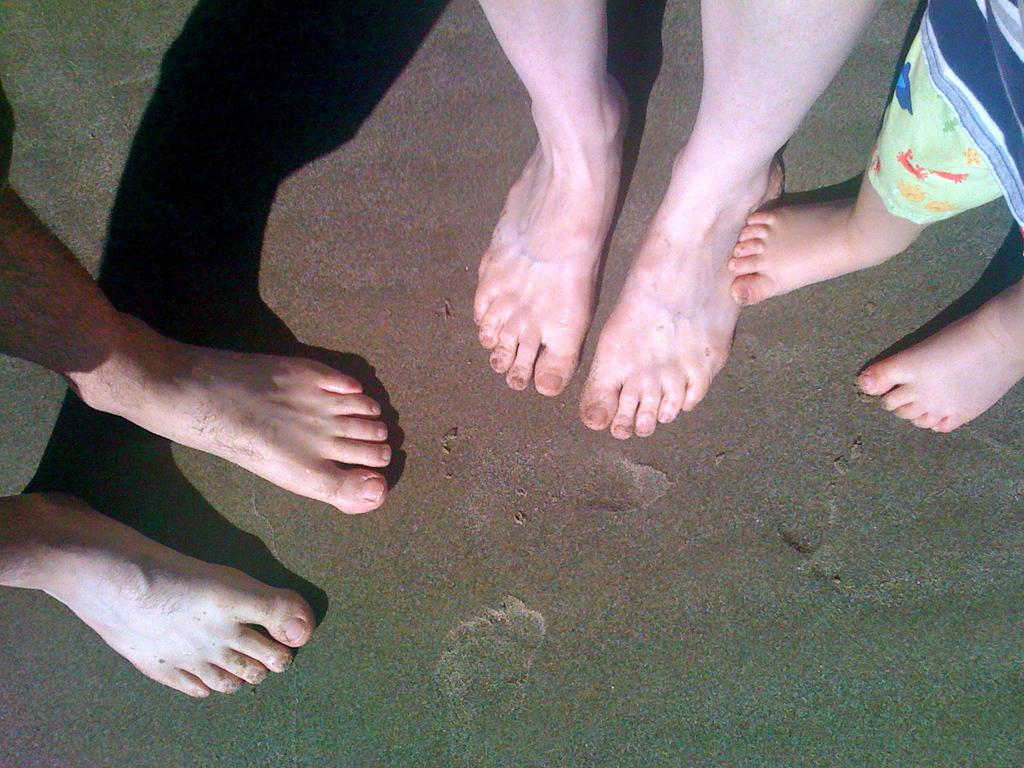How many sets of legs are visible in the image? There are legs of three persons in the image. What type of surface can be seen in the image? There is sand in the image. What type of frame is visible in the image? There is no frame present in the image. What type of growth can be seen in the image? There is no growth visible in the image; it only shows legs and sand. 